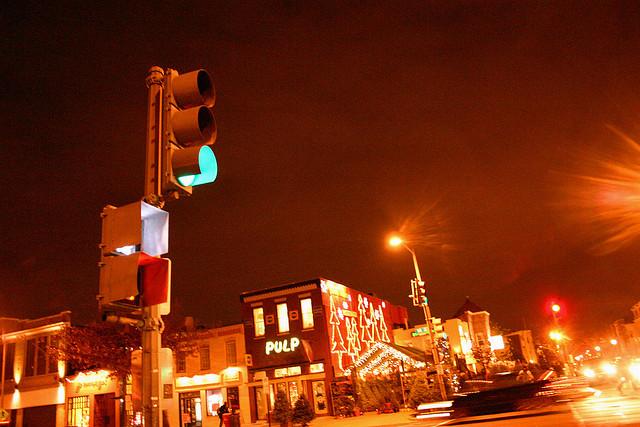What time of day is it?
Answer briefly. Night. What can be seen for sale?
Quick response, please. Christmas trees. What color is the traffic light?
Answer briefly. Green. 